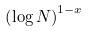Convert formula to latex. <formula><loc_0><loc_0><loc_500><loc_500>\left ( \log N \right ) ^ { 1 - x }</formula> 